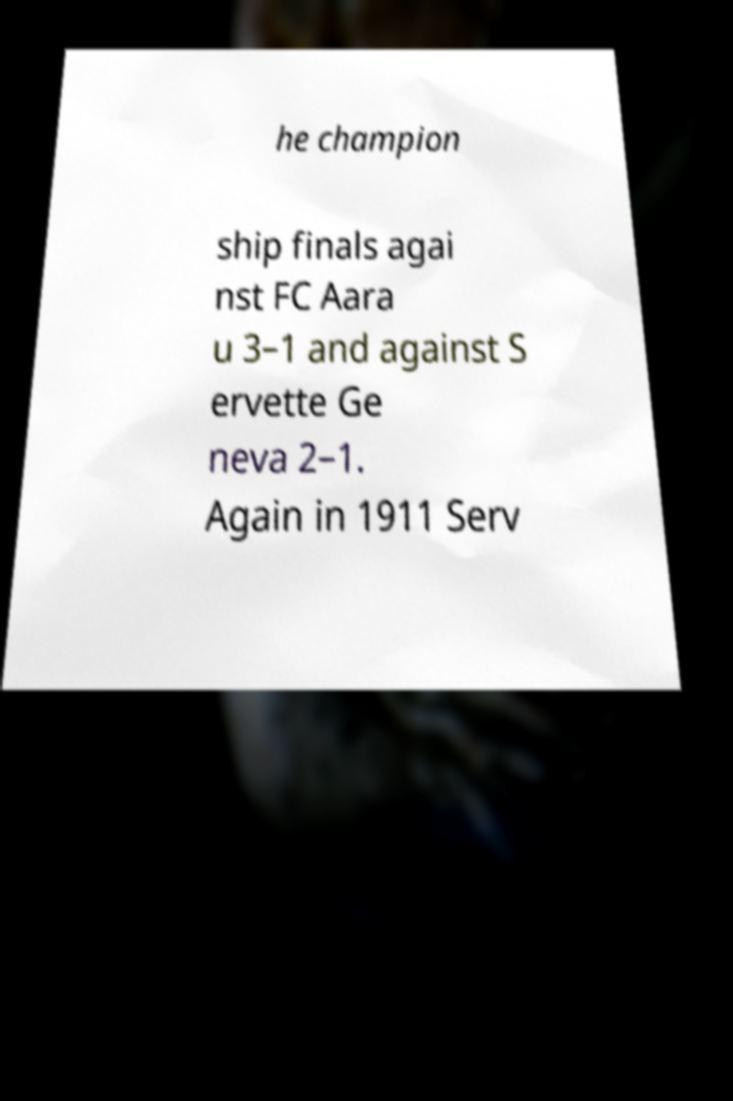There's text embedded in this image that I need extracted. Can you transcribe it verbatim? he champion ship finals agai nst FC Aara u 3–1 and against S ervette Ge neva 2–1. Again in 1911 Serv 